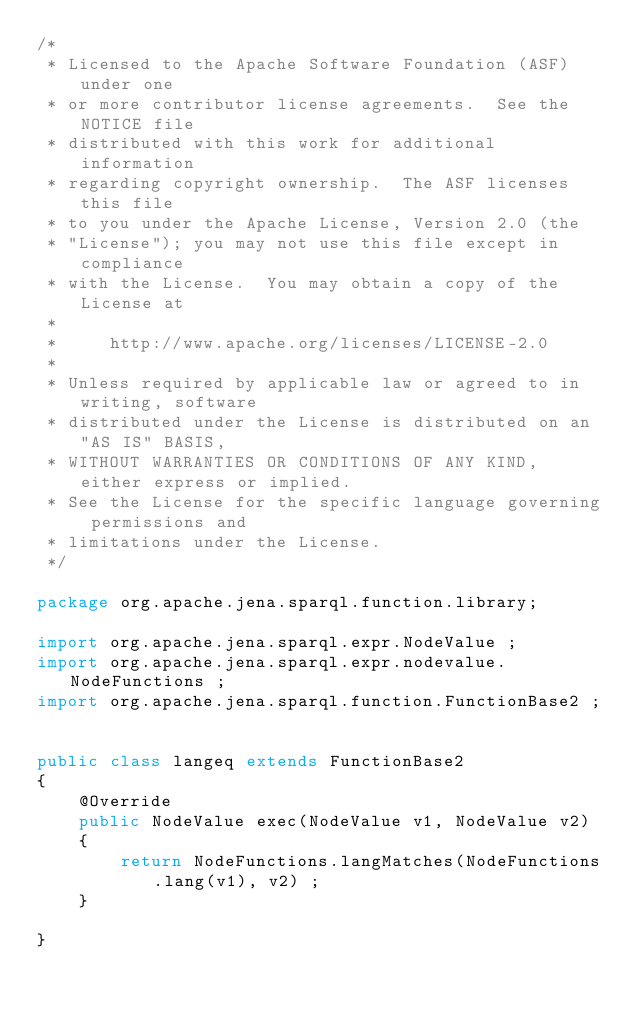<code> <loc_0><loc_0><loc_500><loc_500><_Java_>/*
 * Licensed to the Apache Software Foundation (ASF) under one
 * or more contributor license agreements.  See the NOTICE file
 * distributed with this work for additional information
 * regarding copyright ownership.  The ASF licenses this file
 * to you under the Apache License, Version 2.0 (the
 * "License"); you may not use this file except in compliance
 * with the License.  You may obtain a copy of the License at
 *
 *     http://www.apache.org/licenses/LICENSE-2.0
 *
 * Unless required by applicable law or agreed to in writing, software
 * distributed under the License is distributed on an "AS IS" BASIS,
 * WITHOUT WARRANTIES OR CONDITIONS OF ANY KIND, either express or implied.
 * See the License for the specific language governing permissions and
 * limitations under the License.
 */

package org.apache.jena.sparql.function.library;

import org.apache.jena.sparql.expr.NodeValue ;
import org.apache.jena.sparql.expr.nodevalue.NodeFunctions ;
import org.apache.jena.sparql.function.FunctionBase2 ;


public class langeq extends FunctionBase2
{
    @Override
    public NodeValue exec(NodeValue v1, NodeValue v2)
    {
        return NodeFunctions.langMatches(NodeFunctions.lang(v1), v2) ;
    }

}
</code> 